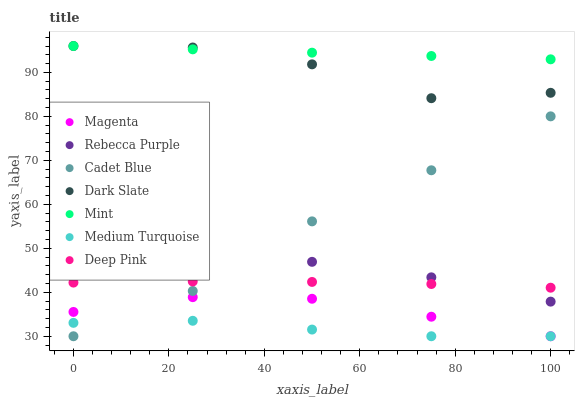Does Medium Turquoise have the minimum area under the curve?
Answer yes or no. Yes. Does Mint have the maximum area under the curve?
Answer yes or no. Yes. Does Dark Slate have the minimum area under the curve?
Answer yes or no. No. Does Dark Slate have the maximum area under the curve?
Answer yes or no. No. Is Mint the smoothest?
Answer yes or no. Yes. Is Dark Slate the roughest?
Answer yes or no. Yes. Is Deep Pink the smoothest?
Answer yes or no. No. Is Deep Pink the roughest?
Answer yes or no. No. Does Cadet Blue have the lowest value?
Answer yes or no. Yes. Does Dark Slate have the lowest value?
Answer yes or no. No. Does Mint have the highest value?
Answer yes or no. Yes. Does Deep Pink have the highest value?
Answer yes or no. No. Is Medium Turquoise less than Deep Pink?
Answer yes or no. Yes. Is Dark Slate greater than Rebecca Purple?
Answer yes or no. Yes. Does Rebecca Purple intersect Cadet Blue?
Answer yes or no. Yes. Is Rebecca Purple less than Cadet Blue?
Answer yes or no. No. Is Rebecca Purple greater than Cadet Blue?
Answer yes or no. No. Does Medium Turquoise intersect Deep Pink?
Answer yes or no. No. 